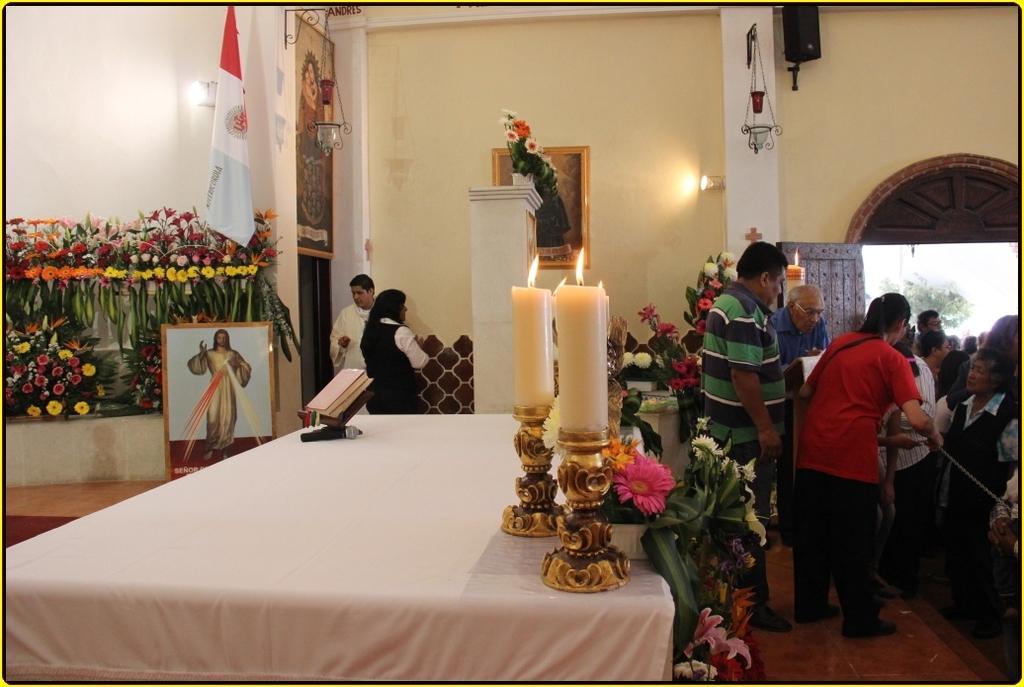In one or two sentences, can you explain what this image depicts? This is an edited picture. I can see group of people. There are candles with the candles stands, flower bouquets, mike, book, flag, frames attached to the walls. I can see a speaker and some other objects, and in the background there are walls. 